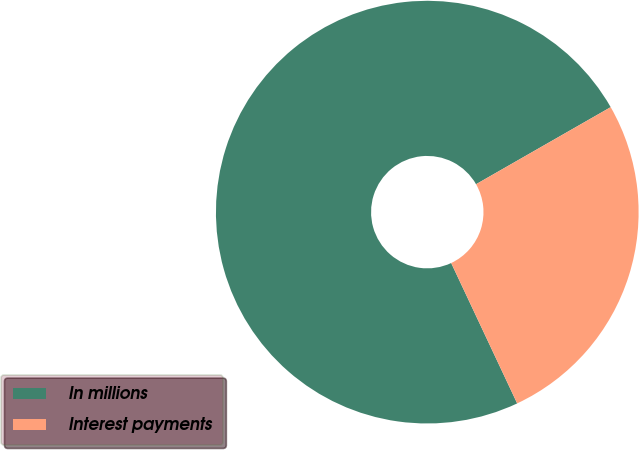Convert chart to OTSL. <chart><loc_0><loc_0><loc_500><loc_500><pie_chart><fcel>In millions<fcel>Interest payments<nl><fcel>73.72%<fcel>26.28%<nl></chart> 